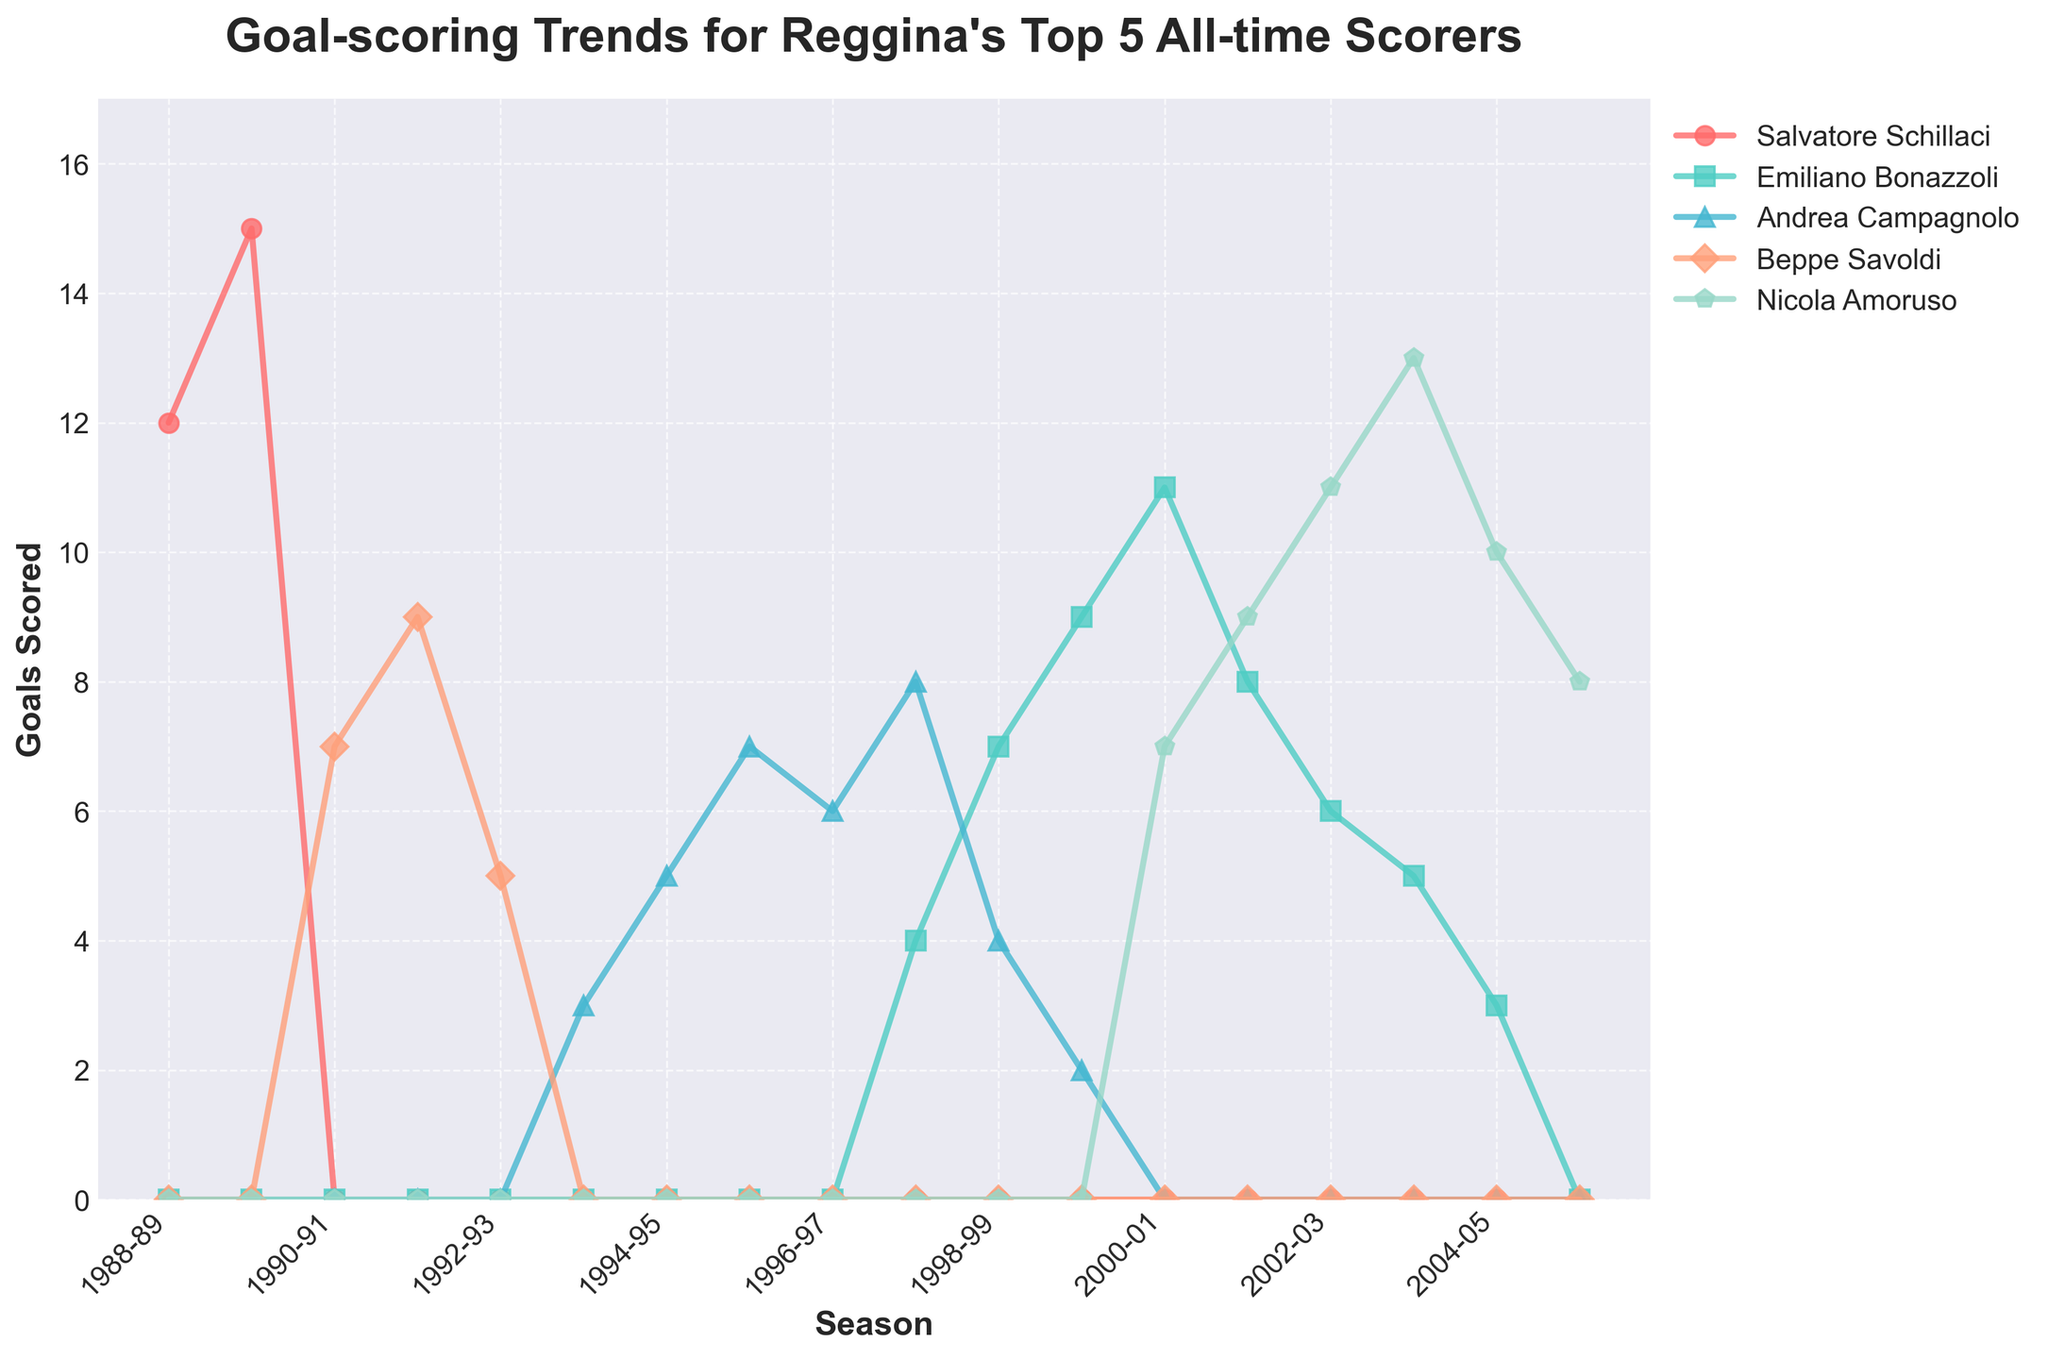Which player scored the most goals in the 1989-90 season? First, find the goals scored by each player in the 1989-90 season. The player with the highest number of goals scored in that season is Salvatore Schillaci with 15 goals.
Answer: Salvatore Schillaci Between which seasons did Emiliano Bonazzoli show the greatest single-season increase in goals scored? Look at Emiliano Bonazzoli's goals scored each season and find the season-to-season differences. The largest increase is from the 1997-98 season to the 1998-99 season, where he went from 4 to 7 goals (an increase of 3).
Answer: 1997-98 to 1998-99 Which player had the highest peak (single-season maximum) in their goal-scoring career? Check the maximum number of goals scored in a single season for each player. The highest peak is 15 goals by Salvatore Schillaci in 1989-90.
Answer: Salvatore Schillaci Sum the total goals scored by Beppe Savoldi over his entire career shown in the chart. Add the goals scored by Beppe Savoldi across all seasons: 7 + 9 + 5 = 21.
Answer: 21 Compare the trends of Salvatore Schillaci and Nicola Amoruso. In which season did Schillaci score the same number of goals as Amoruso for the first time? Compare the goals scored by Salvatore Schillaci and Nicola Amoruso across all seasons. The first season where they both scored the same number of goals is 2000-01, with 0 goals each.
Answer: 2000-01 Which player's goals scored graph has the steepest initial increase? Look at the initial increase in goals for each player. Beppe Savoldi's graph has the steepest initial increase from 0 to 7 goals between 1989-90 and 1990-91.
Answer: Beppe Savoldi What is the average number of goals scored by Emiliano Bonazzoli per season over his entire career? Sum the goals scored by Emiliano Bonazzoli: 4 + 7 + 9 + 11 + 8 + 6 + 5 + 3 = 53. Divide by the number of seasons (8) to get the average: 53 / 8 = 6.625.
Answer: 6.625 Identify the player with the most consistent performance by finding the player with goals scored closest to their average in most seasons. Calculate the average goals per season for each player and compare each season's goals to that average. Emiliano Bonazzoli has the most consistent performance, scoring around his average of 6.625 goals per season.
Answer: Emiliano Bonazzoli Which player's graph ends at the highest value in the final season shown on the chart? Look at the goals scored by each player in the 2005-06 season. Nicola Amoruso has the highest final season value with 8 goals.
Answer: Nicola Amoruso 